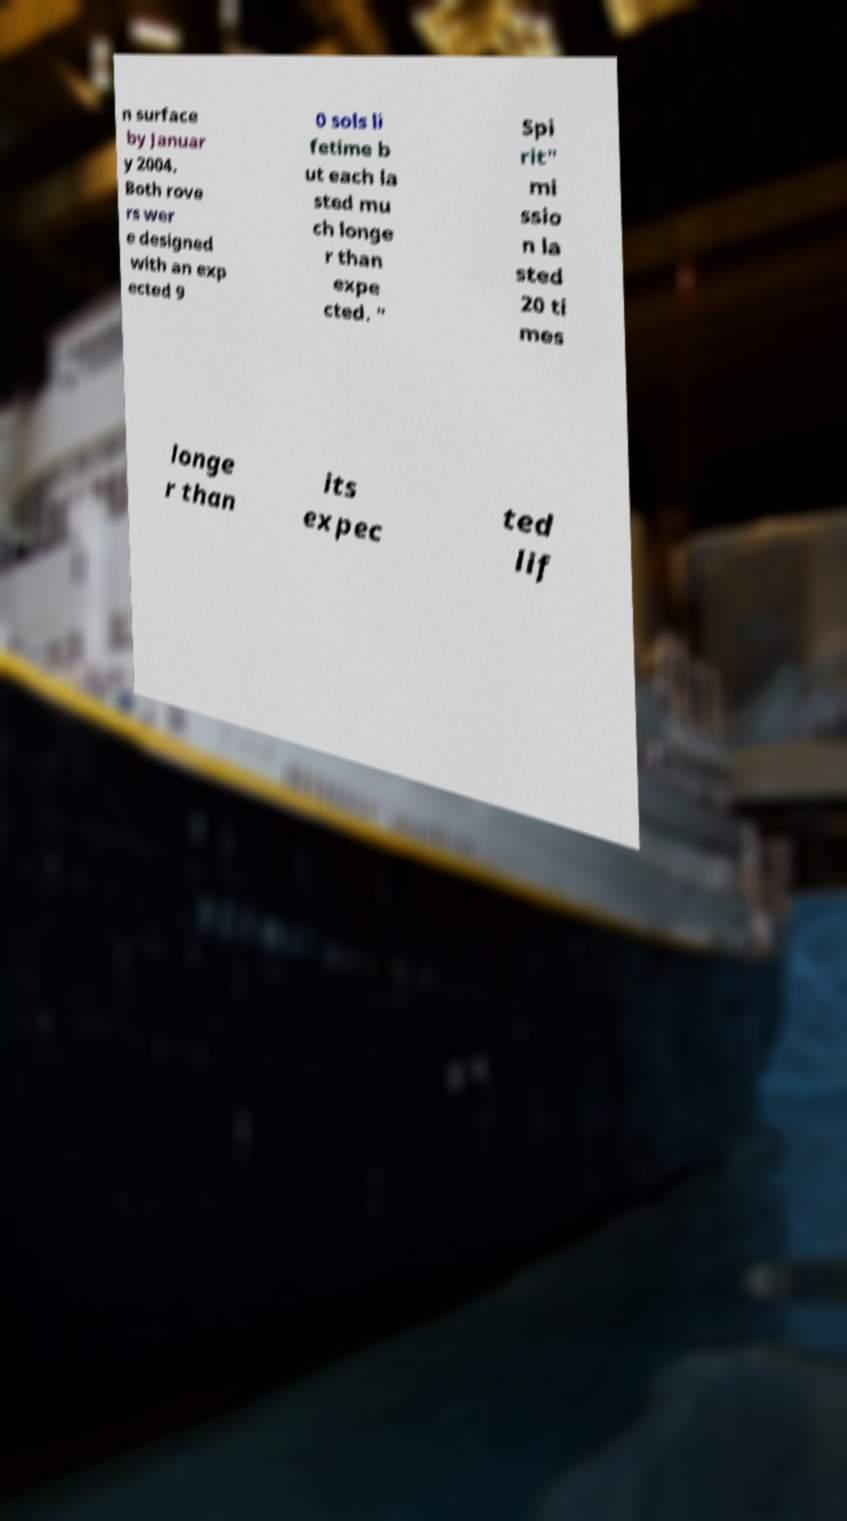There's text embedded in this image that I need extracted. Can you transcribe it verbatim? n surface by Januar y 2004. Both rove rs wer e designed with an exp ected 9 0 sols li fetime b ut each la sted mu ch longe r than expe cted. " Spi rit" mi ssio n la sted 20 ti mes longe r than its expec ted lif 